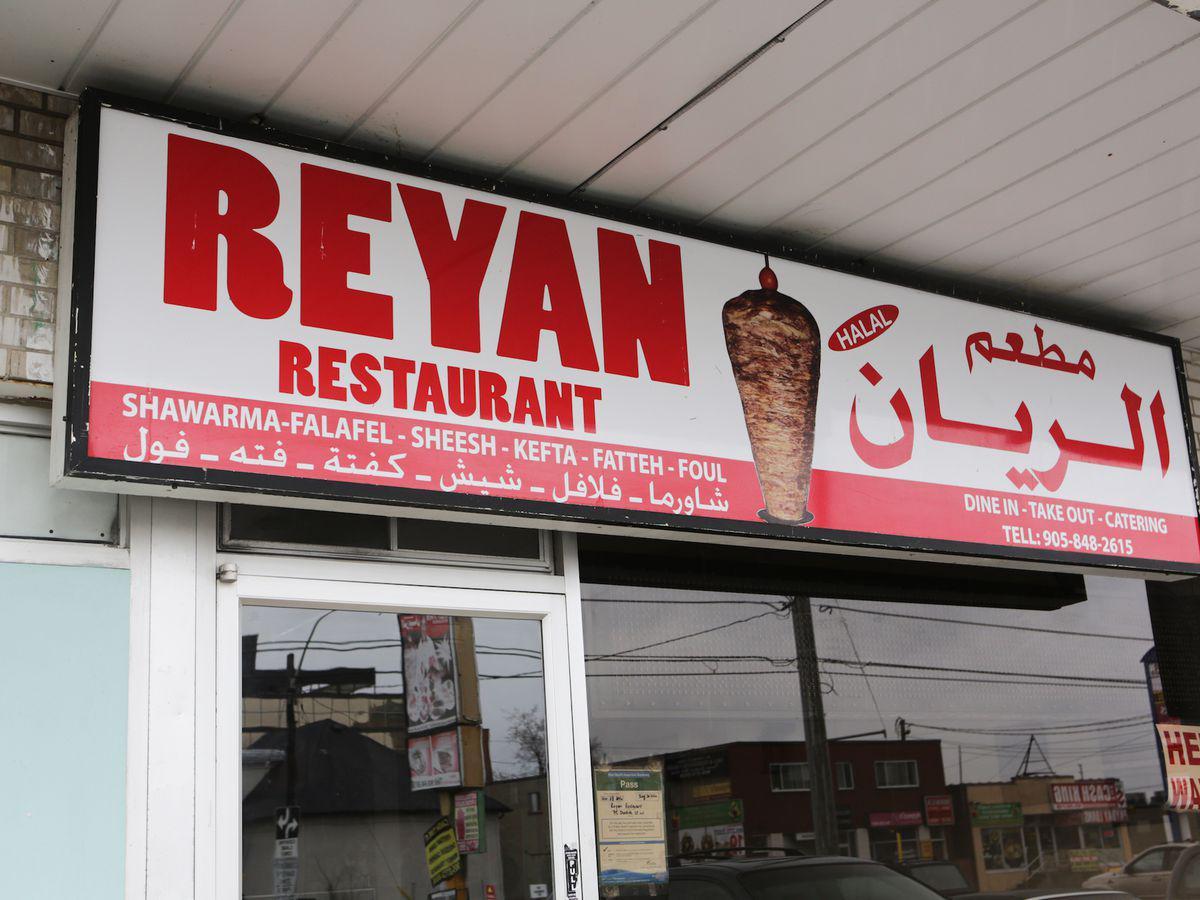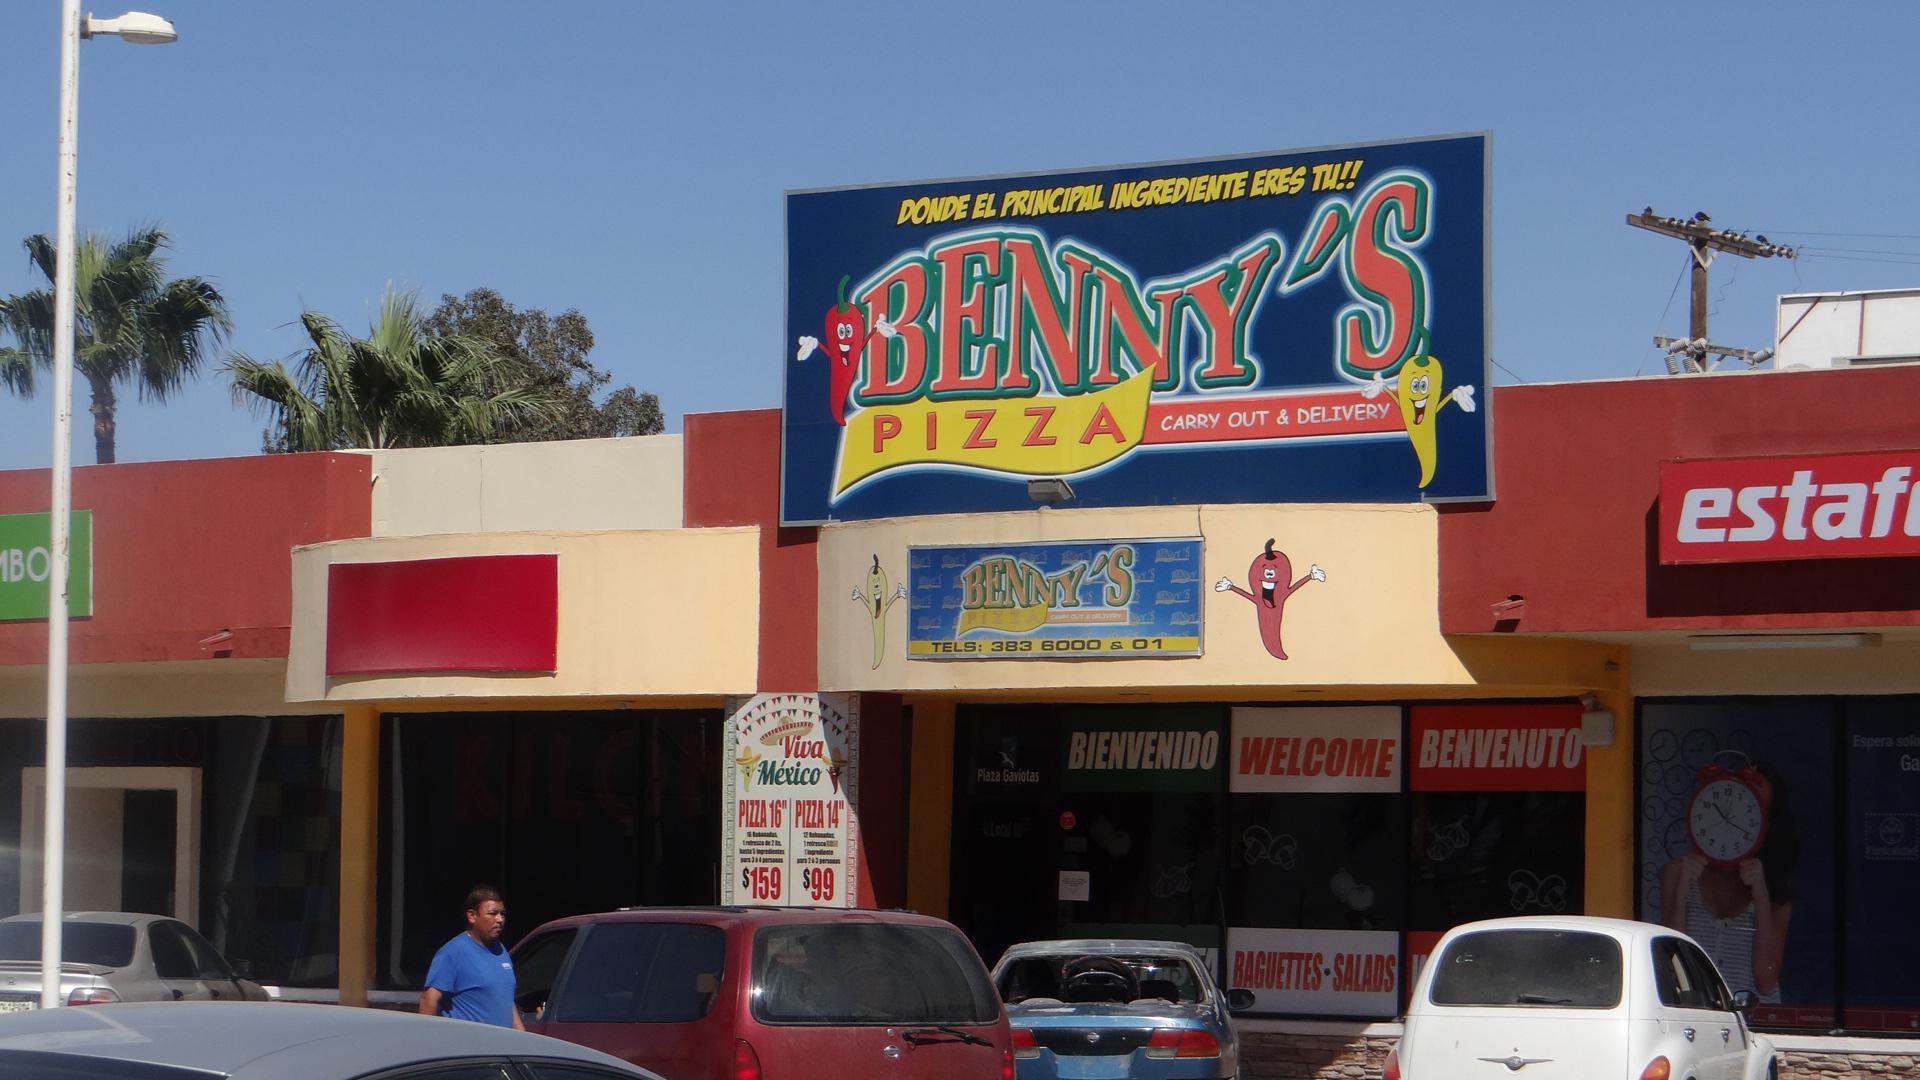The first image is the image on the left, the second image is the image on the right. For the images displayed, is the sentence "One of the restaurants serves pizza." factually correct? Answer yes or no. Yes. The first image is the image on the left, the second image is the image on the right. Examine the images to the left and right. Is the description "There are tables under the awning in one image." accurate? Answer yes or no. No. 